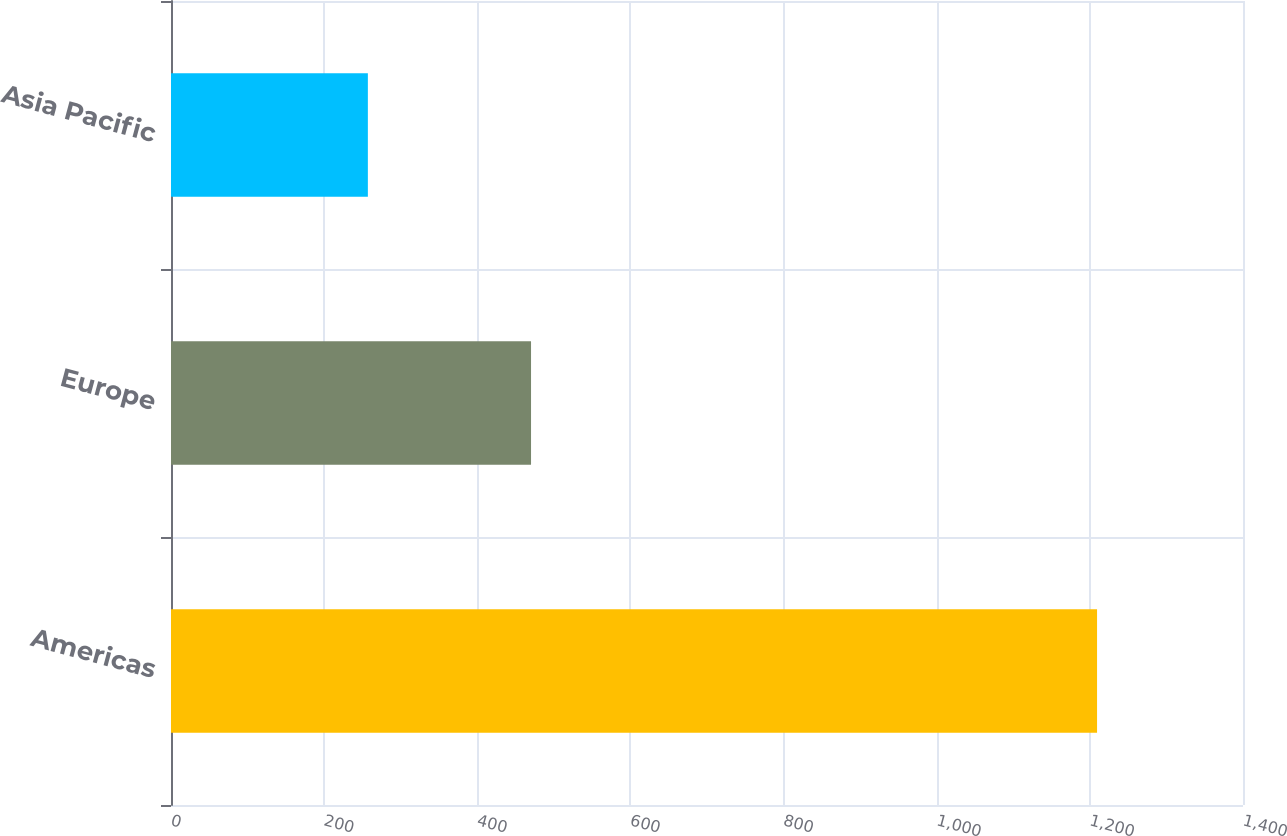Convert chart to OTSL. <chart><loc_0><loc_0><loc_500><loc_500><bar_chart><fcel>Americas<fcel>Europe<fcel>Asia Pacific<nl><fcel>1209.4<fcel>470.2<fcel>257.1<nl></chart> 